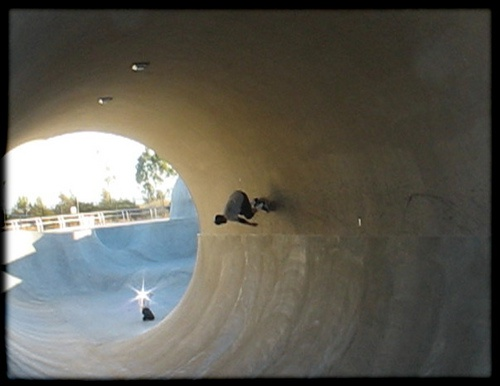Describe the objects in this image and their specific colors. I can see people in black and gray tones, people in black, gray, and darkblue tones, and skateboard in black and gray tones in this image. 